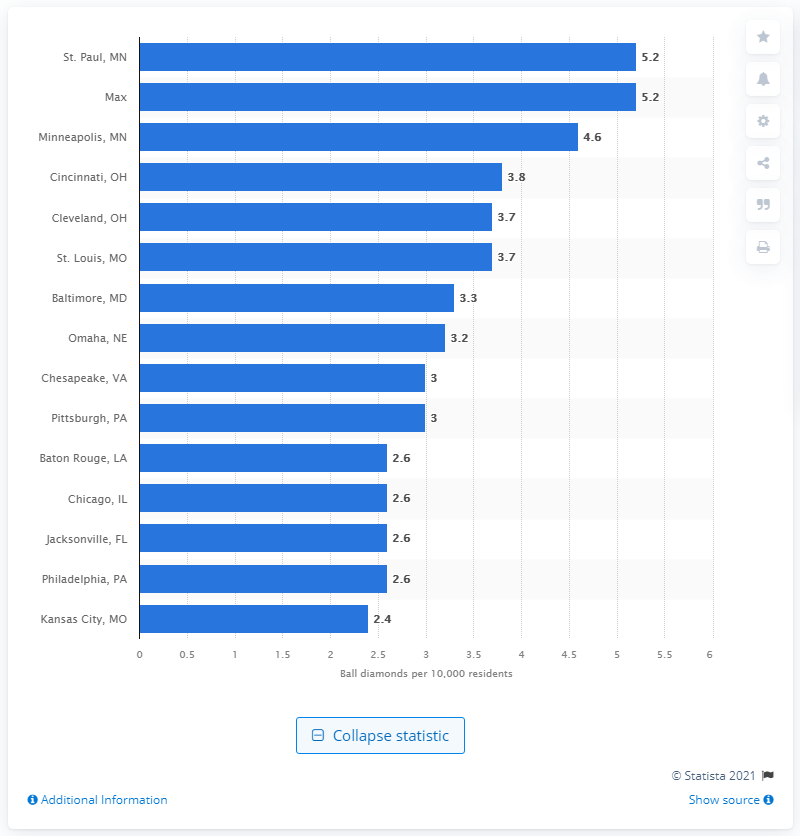Draw attention to some important aspects in this diagram. Minneapolis had an average of 4.6 ball diamonds per 10,000 residents in 2020. 